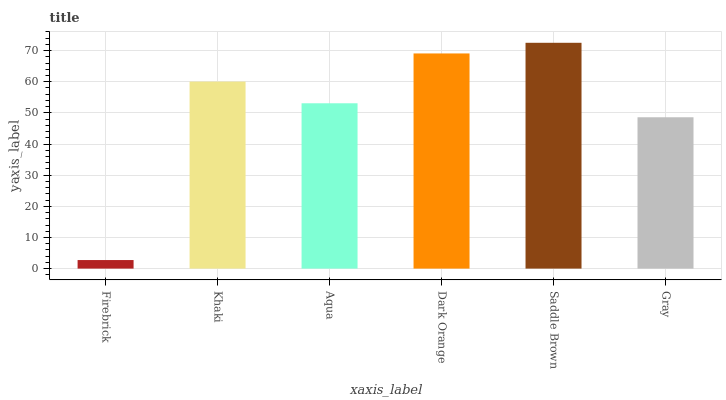Is Firebrick the minimum?
Answer yes or no. Yes. Is Saddle Brown the maximum?
Answer yes or no. Yes. Is Khaki the minimum?
Answer yes or no. No. Is Khaki the maximum?
Answer yes or no. No. Is Khaki greater than Firebrick?
Answer yes or no. Yes. Is Firebrick less than Khaki?
Answer yes or no. Yes. Is Firebrick greater than Khaki?
Answer yes or no. No. Is Khaki less than Firebrick?
Answer yes or no. No. Is Khaki the high median?
Answer yes or no. Yes. Is Aqua the low median?
Answer yes or no. Yes. Is Saddle Brown the high median?
Answer yes or no. No. Is Firebrick the low median?
Answer yes or no. No. 